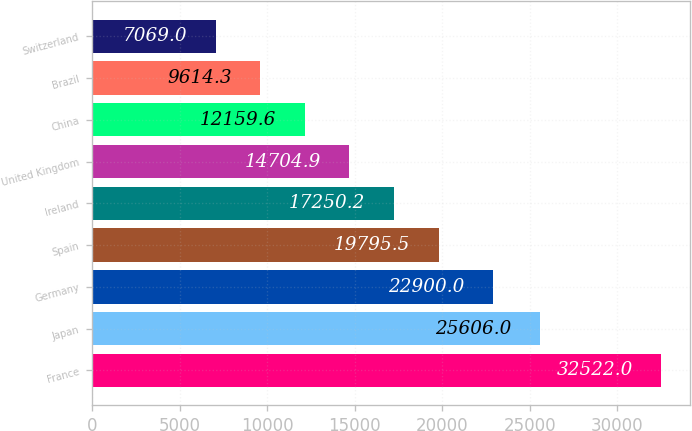Convert chart. <chart><loc_0><loc_0><loc_500><loc_500><bar_chart><fcel>France<fcel>Japan<fcel>Germany<fcel>Spain<fcel>Ireland<fcel>United Kingdom<fcel>China<fcel>Brazil<fcel>Switzerland<nl><fcel>32522<fcel>25606<fcel>22900<fcel>19795.5<fcel>17250.2<fcel>14704.9<fcel>12159.6<fcel>9614.3<fcel>7069<nl></chart> 